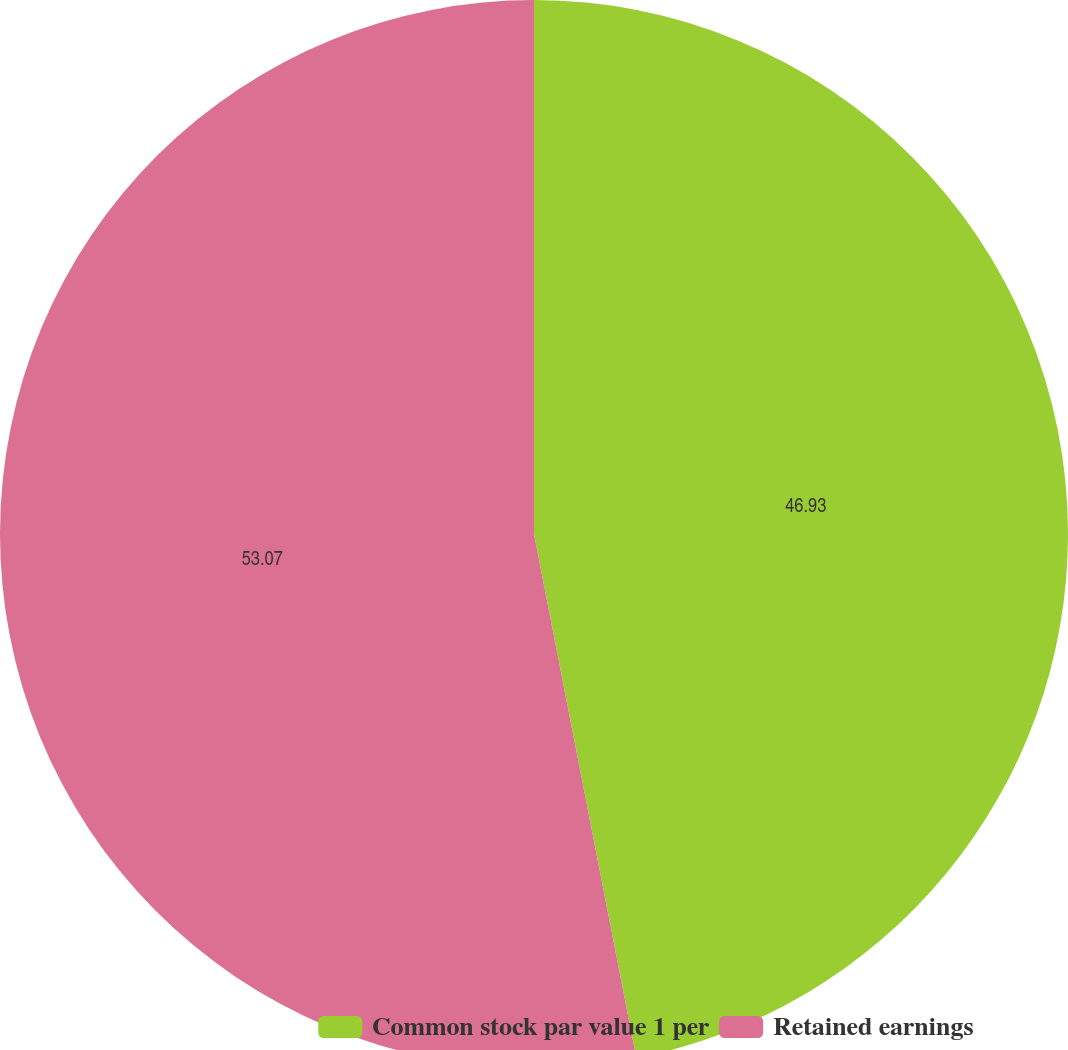Convert chart. <chart><loc_0><loc_0><loc_500><loc_500><pie_chart><fcel>Common stock par value 1 per<fcel>Retained earnings<nl><fcel>46.93%<fcel>53.07%<nl></chart> 